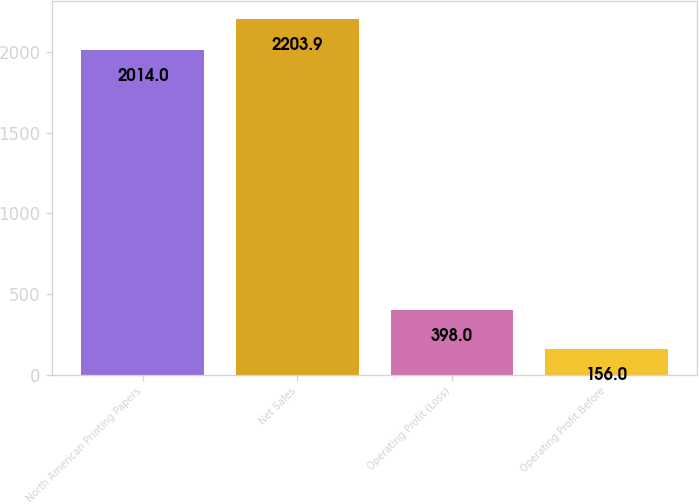<chart> <loc_0><loc_0><loc_500><loc_500><bar_chart><fcel>North American Printing Papers<fcel>Net Sales<fcel>Operating Profit (Loss)<fcel>Operating Profit Before<nl><fcel>2014<fcel>2203.9<fcel>398<fcel>156<nl></chart> 